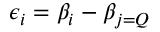<formula> <loc_0><loc_0><loc_500><loc_500>\epsilon _ { i } = \beta _ { i } - \beta _ { j = Q }</formula> 